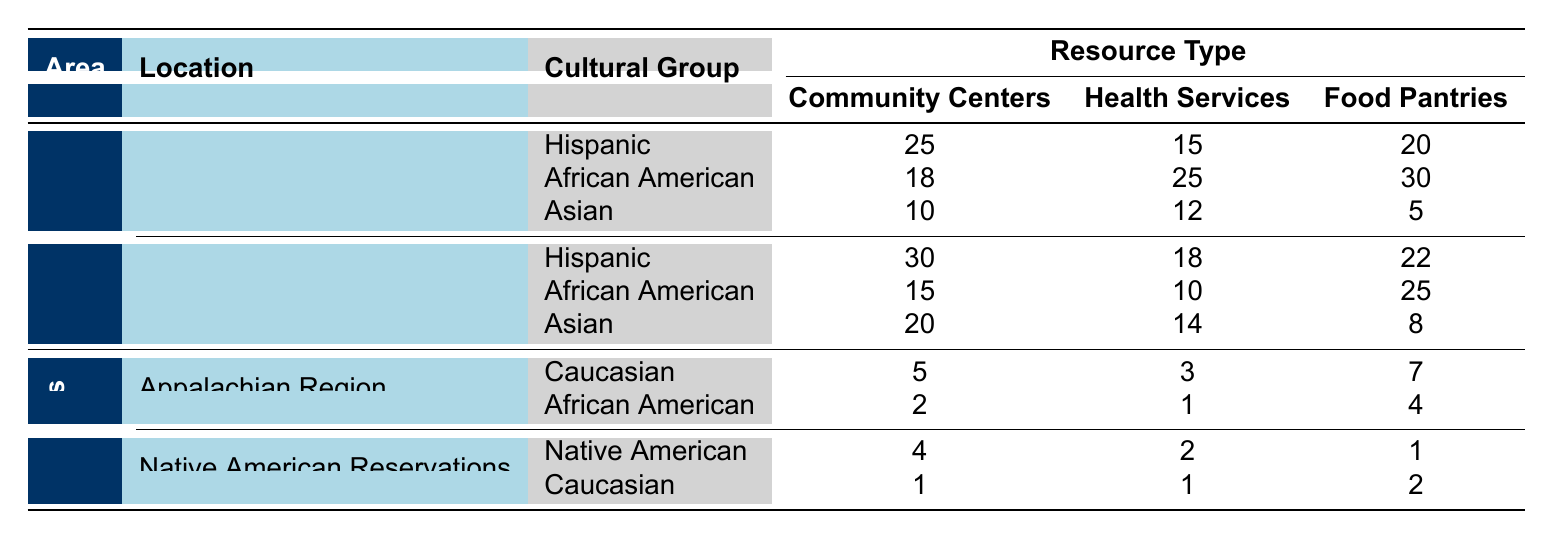What is the total number of Community Centers for Hispanic groups in both New York City and Los Angeles? In New York City, the Hispanic group has 25 Community Centers, and in Los Angeles, it has 30. Adding these together gives 25 + 30 = 55.
Answer: 55 Which cultural group has the highest number of Food Pantries in New York City? The table shows three cultural groups in New York City: Hispanic (20), African American (30), and Asian (5). The highest number of Food Pantries is 30 for the African American group.
Answer: African American Is there more Health Services available for the Caucasian or the African American group in the Appalachian Region? In the Appalachian Region, the Caucasian group has 3 Health Services and the African American group has 1. Comparing these two figures, 3 is greater than 1.
Answer: Caucasian What is the average number of Food Pantries for Asian groups across both urban areas? The Asian group has 5 Food Pantries in New York City and 8 in Los Angeles. To find the average, you add these two numbers: 5 + 8 = 13, then divide by 2 (the number of data points): 13 / 2 = 6.5.
Answer: 6.5 Are there more Community Centers in the Native American Reservations than in the Appalachian Region for the Caucasian group? The Caucasian group has 1 Community Center in Native American Reservations and 5 in the Appalachian Region. Comparing these figures shows that 5 is more than 1.
Answer: No Which urban area has the most total Health Services available across all cultural groups? In New York City, the total number of Health Services is 15 (Hispanic) + 25 (African American) + 12 (Asian) = 52. In Los Angeles, the totals are 18 + 10 + 14 = 42. Comparing 52 and 42 shows New York City has more.
Answer: New York City What is the combined total of Community Centers and Health Services for the African American group in both urban areas? The African American group has 18 Community Centers and 25 Health Services in New York City, and 15 Community Centers and 10 Health Services in Los Angeles. Adding these gives: (18 + 25) + (15 + 10) = 43 + 25 = 68.
Answer: 68 Is it true that the Asian group has more Food Pantries in Los Angeles than in New York City? The Asian group has 8 Food Pantries in Los Angeles and 5 in New York City. Since 8 is greater than 5, this statement is true.
Answer: Yes 